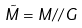Convert formula to latex. <formula><loc_0><loc_0><loc_500><loc_500>\tilde { M } = M / / G</formula> 